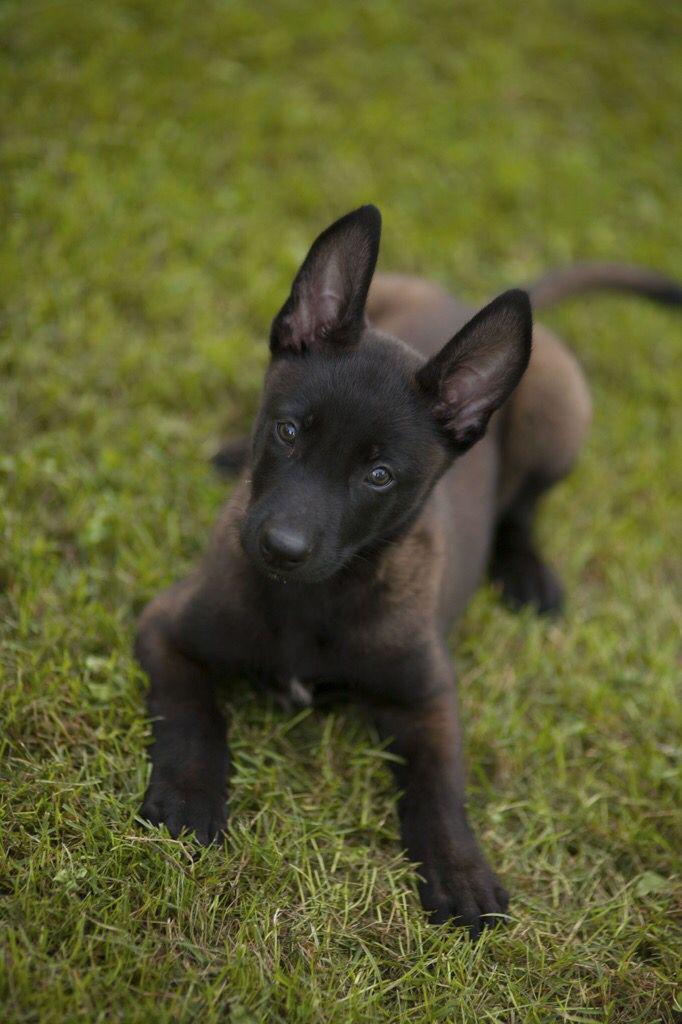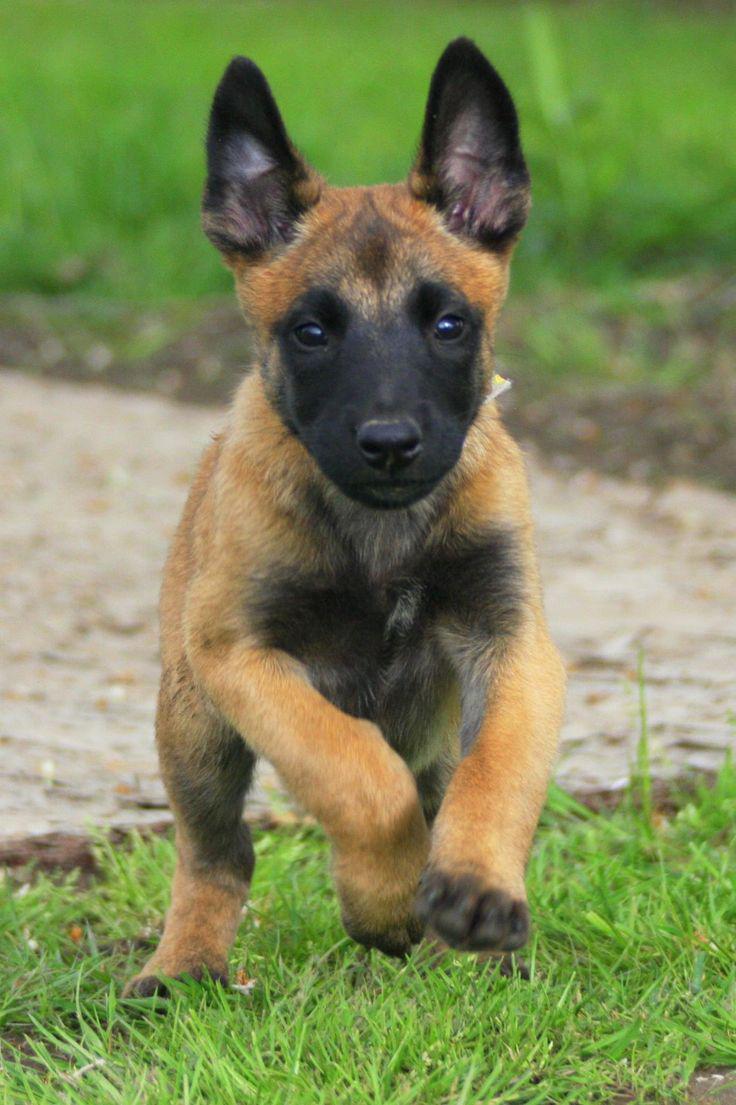The first image is the image on the left, the second image is the image on the right. For the images displayed, is the sentence "A puppy is running through the grass toward the camera." factually correct? Answer yes or no. Yes. The first image is the image on the left, the second image is the image on the right. Analyze the images presented: Is the assertion "At least one dog is wearing a leash." valid? Answer yes or no. No. 